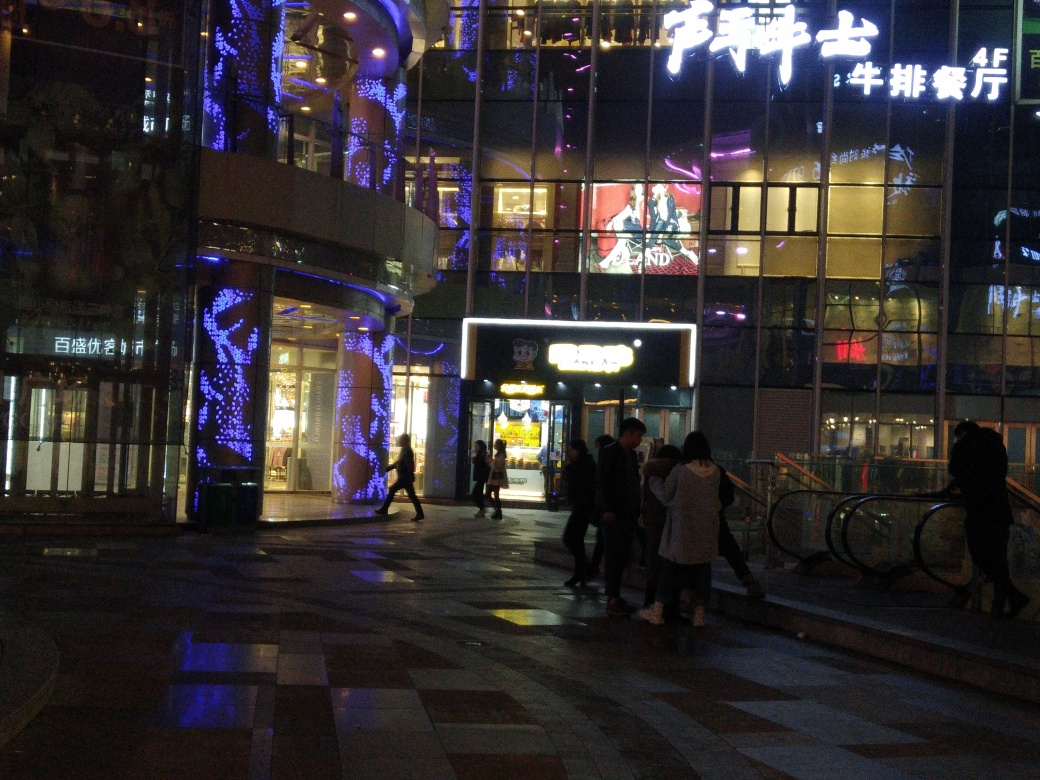Can you describe the style of lighting and decorations seen in this place? Certainly! The area is adorned with modern and elegant lighting, including vertical light strips that cascade down the columns, creating a vibrant and dynamic atmosphere. The blue and purple hues contribute to a cool and contemporary vibe that is both inviting and stylish. 